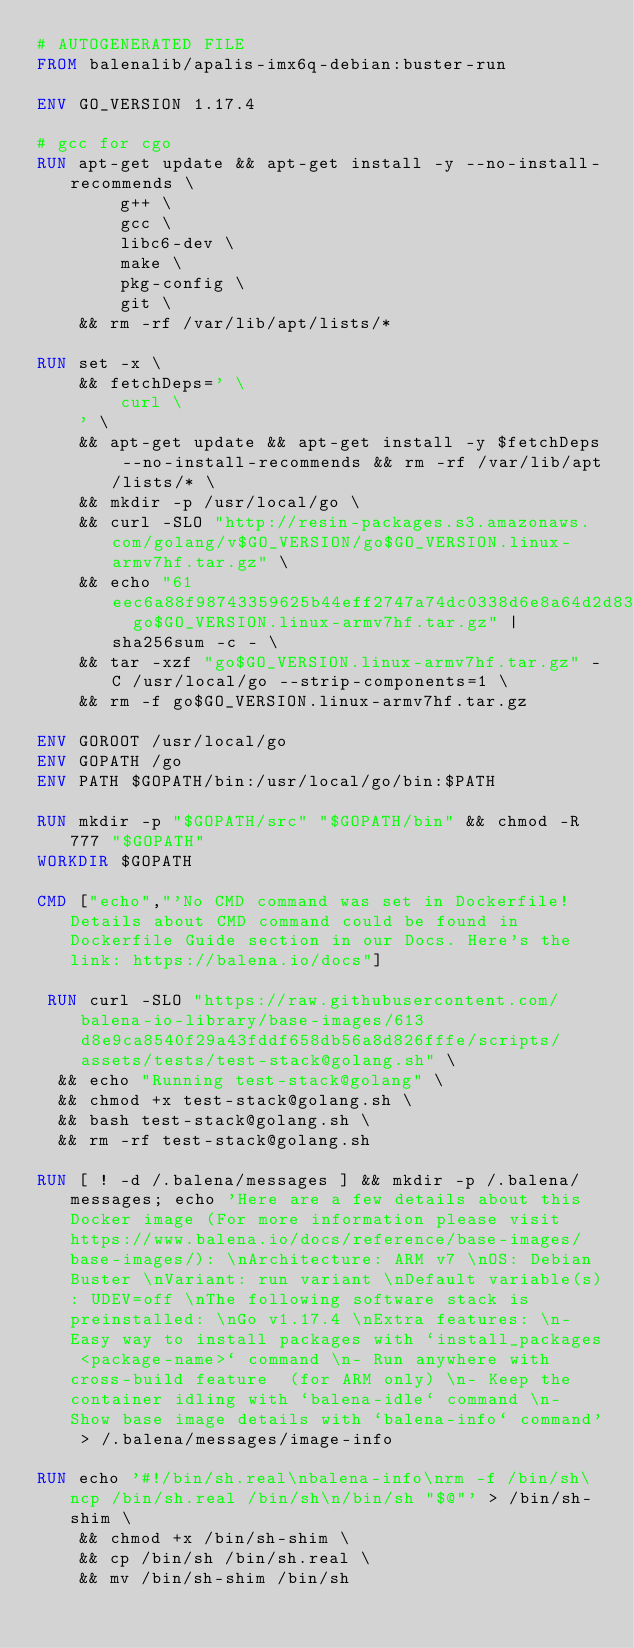Convert code to text. <code><loc_0><loc_0><loc_500><loc_500><_Dockerfile_># AUTOGENERATED FILE
FROM balenalib/apalis-imx6q-debian:buster-run

ENV GO_VERSION 1.17.4

# gcc for cgo
RUN apt-get update && apt-get install -y --no-install-recommends \
		g++ \
		gcc \
		libc6-dev \
		make \
		pkg-config \
		git \
	&& rm -rf /var/lib/apt/lists/*

RUN set -x \
	&& fetchDeps=' \
		curl \
	' \
	&& apt-get update && apt-get install -y $fetchDeps --no-install-recommends && rm -rf /var/lib/apt/lists/* \
	&& mkdir -p /usr/local/go \
	&& curl -SLO "http://resin-packages.s3.amazonaws.com/golang/v$GO_VERSION/go$GO_VERSION.linux-armv7hf.tar.gz" \
	&& echo "61eec6a88f98743359625b44eff2747a74dc0338d6e8a64d2d838f95dbd7050d  go$GO_VERSION.linux-armv7hf.tar.gz" | sha256sum -c - \
	&& tar -xzf "go$GO_VERSION.linux-armv7hf.tar.gz" -C /usr/local/go --strip-components=1 \
	&& rm -f go$GO_VERSION.linux-armv7hf.tar.gz

ENV GOROOT /usr/local/go
ENV GOPATH /go
ENV PATH $GOPATH/bin:/usr/local/go/bin:$PATH

RUN mkdir -p "$GOPATH/src" "$GOPATH/bin" && chmod -R 777 "$GOPATH"
WORKDIR $GOPATH

CMD ["echo","'No CMD command was set in Dockerfile! Details about CMD command could be found in Dockerfile Guide section in our Docs. Here's the link: https://balena.io/docs"]

 RUN curl -SLO "https://raw.githubusercontent.com/balena-io-library/base-images/613d8e9ca8540f29a43fddf658db56a8d826fffe/scripts/assets/tests/test-stack@golang.sh" \
  && echo "Running test-stack@golang" \
  && chmod +x test-stack@golang.sh \
  && bash test-stack@golang.sh \
  && rm -rf test-stack@golang.sh 

RUN [ ! -d /.balena/messages ] && mkdir -p /.balena/messages; echo 'Here are a few details about this Docker image (For more information please visit https://www.balena.io/docs/reference/base-images/base-images/): \nArchitecture: ARM v7 \nOS: Debian Buster \nVariant: run variant \nDefault variable(s): UDEV=off \nThe following software stack is preinstalled: \nGo v1.17.4 \nExtra features: \n- Easy way to install packages with `install_packages <package-name>` command \n- Run anywhere with cross-build feature  (for ARM only) \n- Keep the container idling with `balena-idle` command \n- Show base image details with `balena-info` command' > /.balena/messages/image-info

RUN echo '#!/bin/sh.real\nbalena-info\nrm -f /bin/sh\ncp /bin/sh.real /bin/sh\n/bin/sh "$@"' > /bin/sh-shim \
	&& chmod +x /bin/sh-shim \
	&& cp /bin/sh /bin/sh.real \
	&& mv /bin/sh-shim /bin/sh</code> 